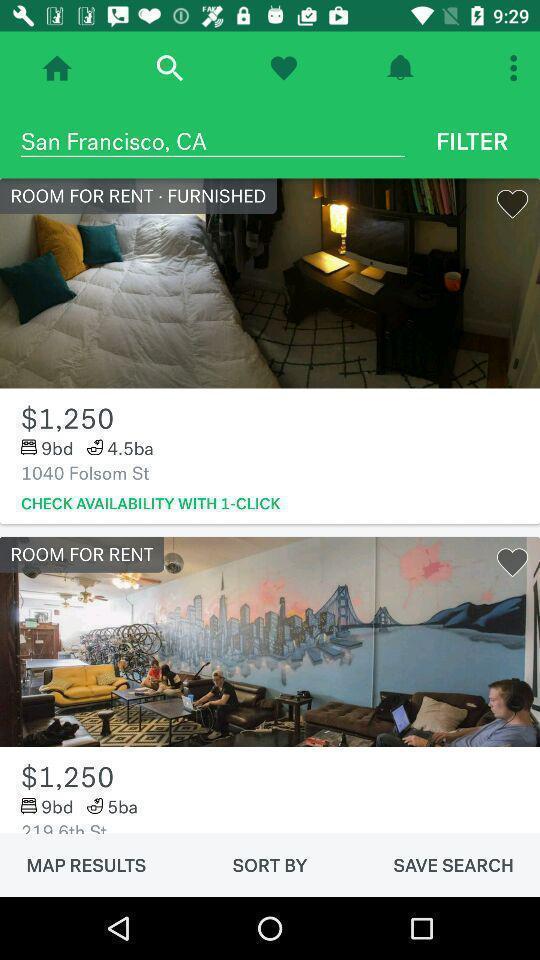Tell me about the visual elements in this screen capture. Page showing various rooms for rent. 